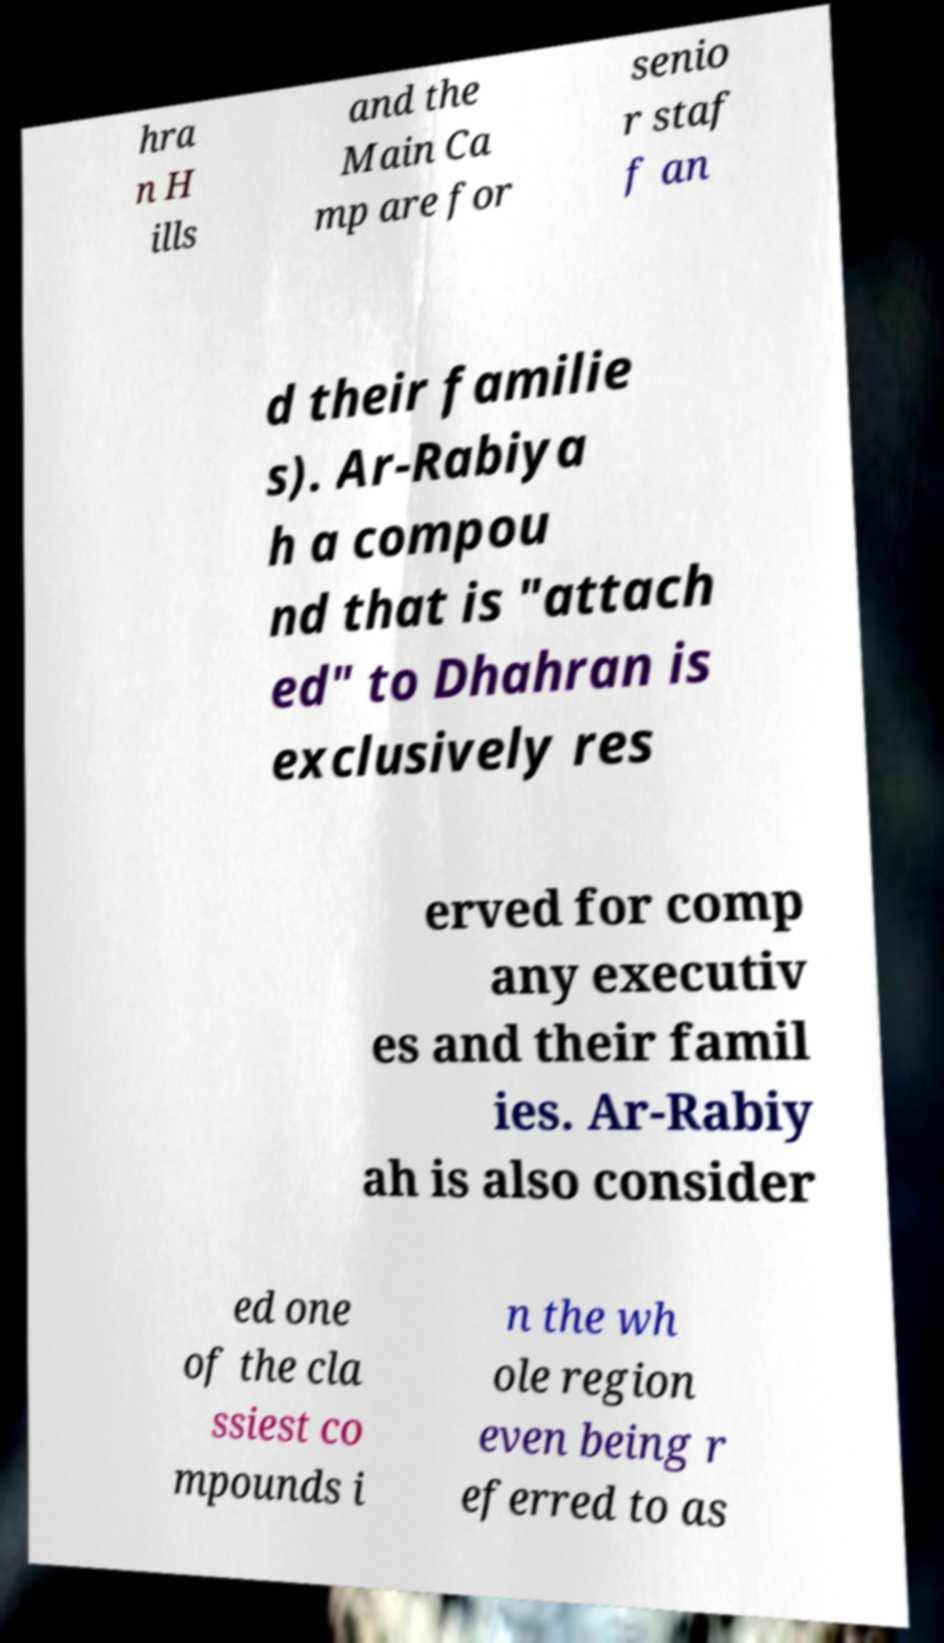There's text embedded in this image that I need extracted. Can you transcribe it verbatim? hra n H ills and the Main Ca mp are for senio r staf f an d their familie s). Ar-Rabiya h a compou nd that is "attach ed" to Dhahran is exclusively res erved for comp any executiv es and their famil ies. Ar-Rabiy ah is also consider ed one of the cla ssiest co mpounds i n the wh ole region even being r eferred to as 